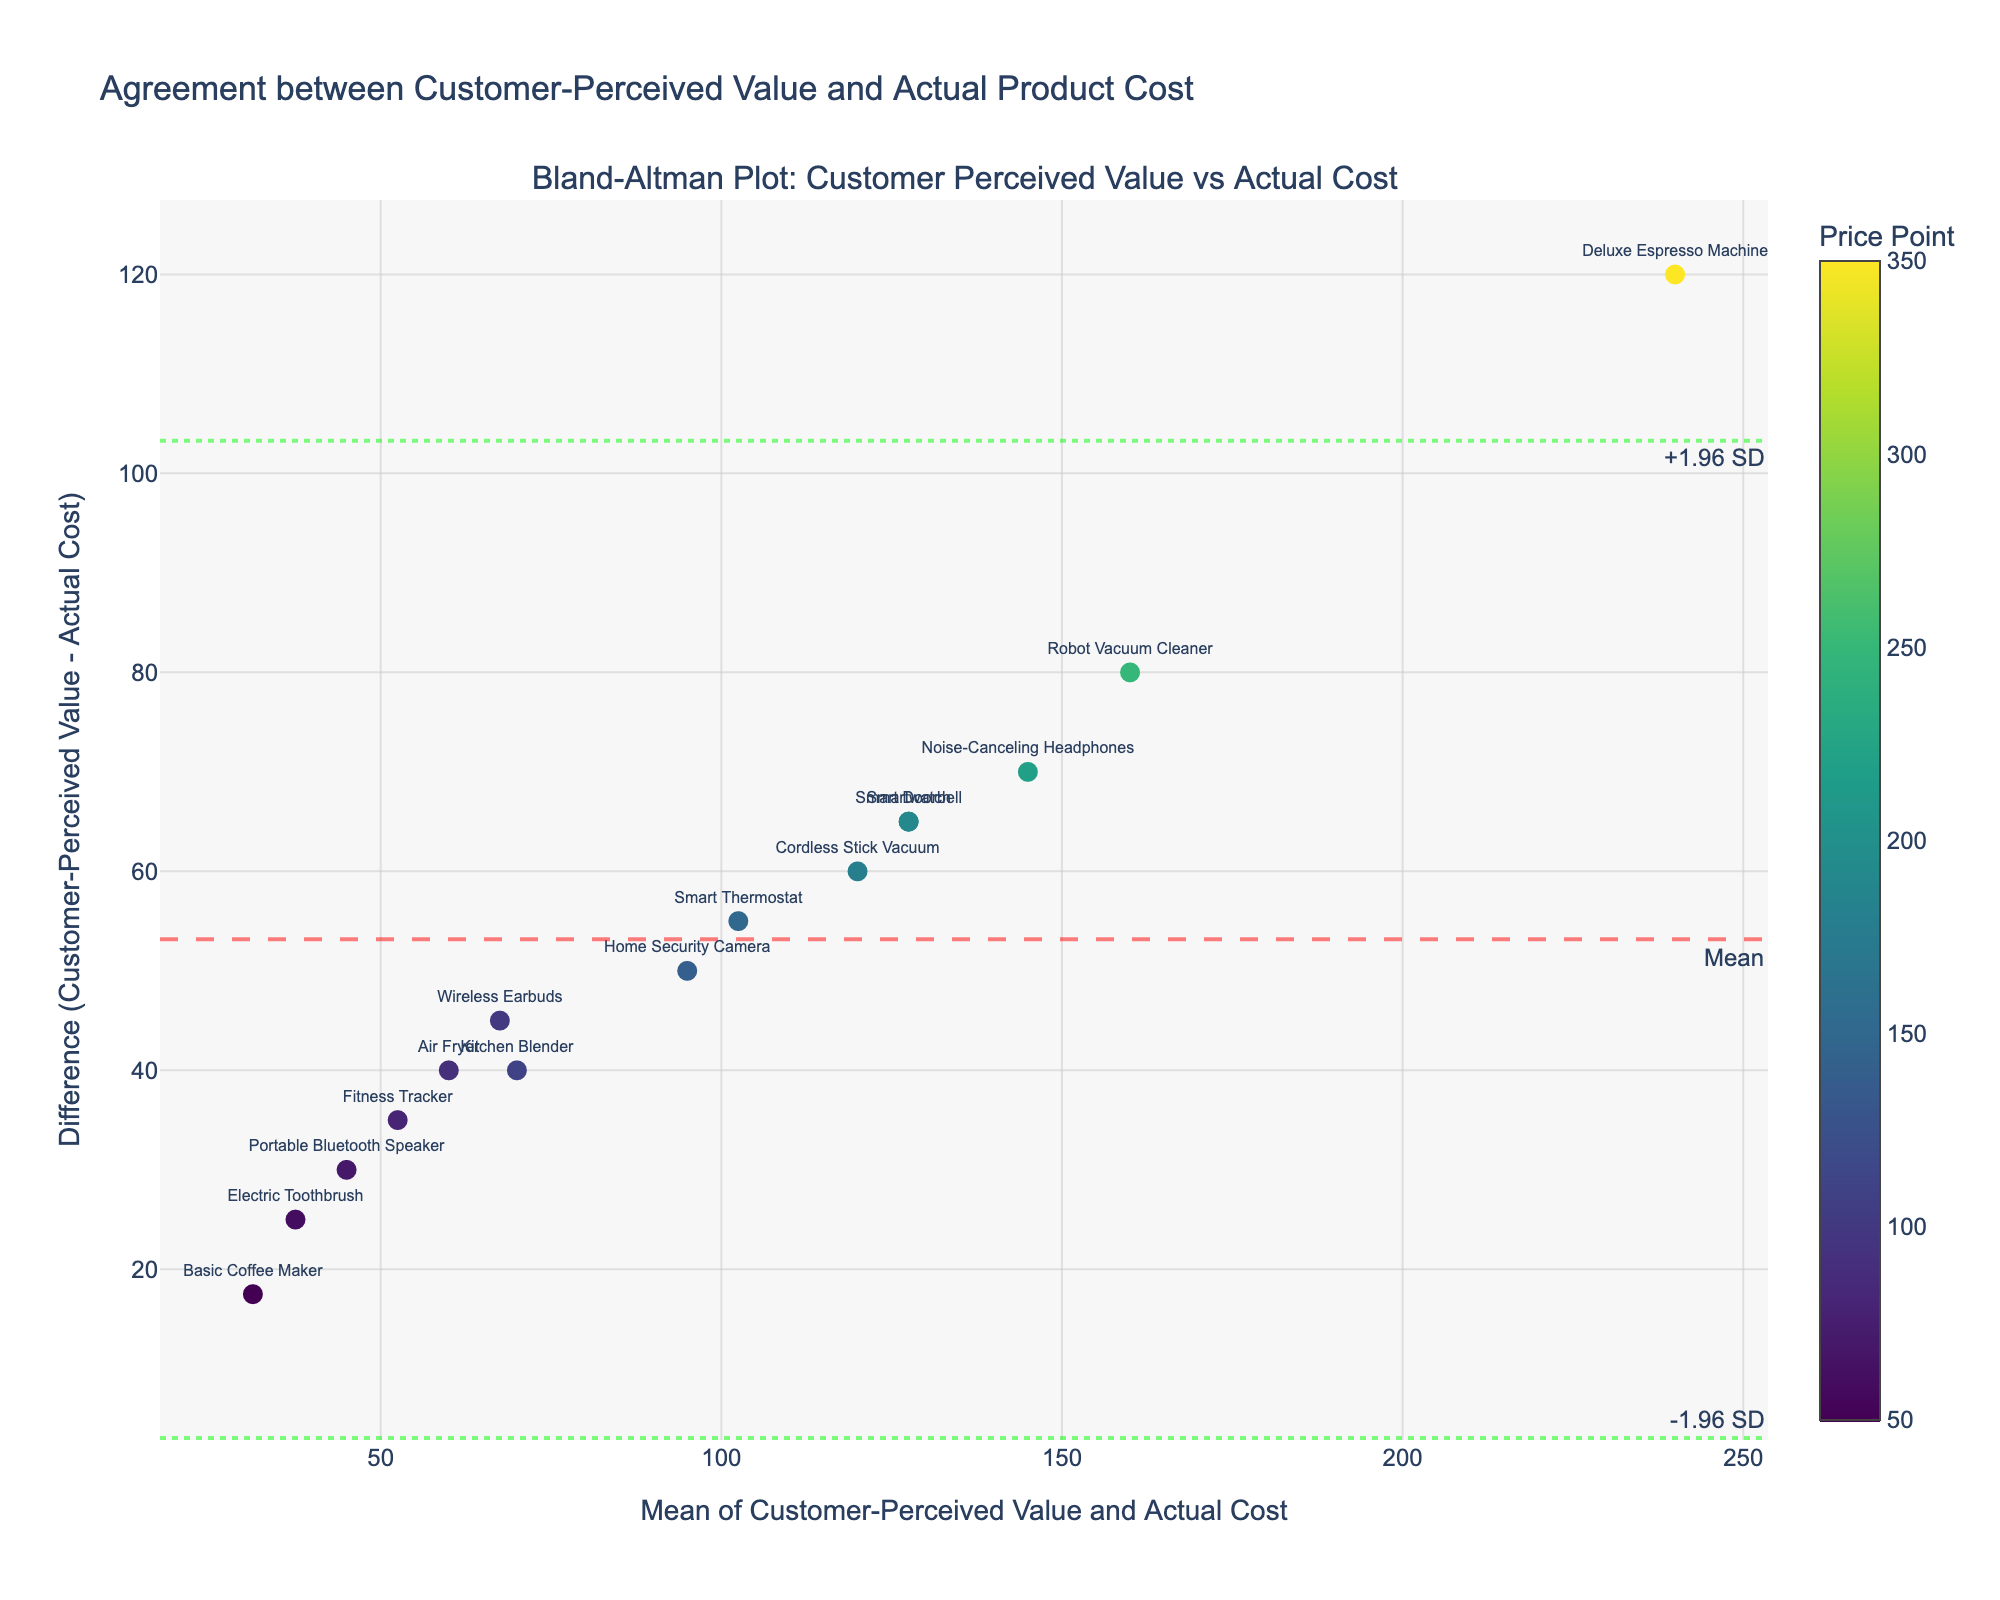What is the title of the plot? The title is typically shown at the top of the plot. It reads "Agreement between Customer-Perceived Value and Actual Product Cost."
Answer: Agreement between Customer-Perceived Value and Actual Product Cost What are the axes titles? The x-axis and y-axis titles are usually placed beside their respective axes. The x-axis title is "Mean of Customer-Perceived Value and Actual Cost," and the y-axis title is "Difference (Customer-Perceived Value - Actual Cost)."
Answer: Mean of Customer-Perceived Value and Actual Cost; Difference (Customer-Perceived Value - Actual Cost) How many standard deviation lines are shown on the plot and what do they represent? There are three horizontal lines: one at the mean difference and two at ±1.96 standard deviations from the mean. They represent the mean difference, the upper limit (mean + 1.96*std), and the lower limit (mean - 1.96*std).
Answer: Three; mean, +1.96 SD, -1.96 SD Which product has the highest price point, and what is its mean value of perceived and actual cost? Look for the point color shaded in the darkest shade, then check the x-axis value for that point. The darkest color represents the Deluxe Espresso Machine with a price point of $349.99. Its mean value is (299.99 + 180.00) / 2 = 239.995.
Answer: Deluxe Espresso Machine; 239.995 Are there any products whose perceived value is lower than the actual cost? Points below the y=0 line on the plot represent products where customer-perceived value is lower than the actual cost. None of the points appear below this line.
Answer: No What is the range of the mean values of customer-perceived value and actual cost? Examine the x-axis limits to see the spread. The lowest value is around 23.75 (Basic Coffee Maker), and the highest value is around 239.995 (Deluxe Espresso Machine).
Answer: Approximately 23.75 to 239.995 Which product has the highest positive difference between perceived value and actual cost, and what is the difference? Find the highest point on the y-axis. This will be the Smart Thermostat, with a difference of 129.99 - 75.00 = 54.99.
Answer: Smart Thermostat; 54.99 How do most products' differences between perceived value and actual cost align with the mean difference line? Observe the scatter points and their proximity to the mean difference line. Most points are above the mean difference line, indicating a generally higher perceived value compared to the actual cost.
Answer: Above the mean difference line Considering the price points' color scale, what price range seems to show the largest differences between perceived value and actual cost? By observing the color scale (usually shown on the side), darker colors (indicating higher price points) like those for Deluxe Espresso Machine and Smart Thermostat seem to show noticeable differences.
Answer: Higher price points What are the actual cost and perceived value for the Air Fryer? Refer to the specific point labeled as Air Fryer. The actual cost is $40.00, and the perceived value is $79.99.
Answer: Actual Cost: $40.00; Perceived Value: $79.99 